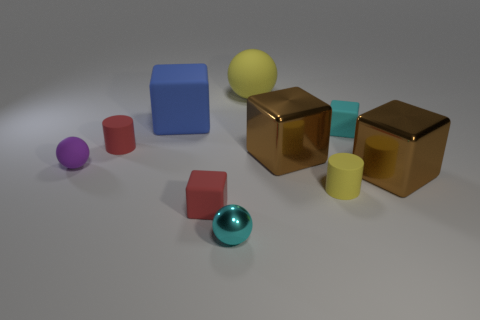Subtract all small red rubber blocks. How many blocks are left? 4 Subtract all cyan blocks. How many blocks are left? 4 Subtract 1 blocks. How many blocks are left? 4 Subtract all yellow cubes. Subtract all gray cylinders. How many cubes are left? 5 Subtract all spheres. How many objects are left? 7 Add 6 tiny purple objects. How many tiny purple objects are left? 7 Add 5 yellow spheres. How many yellow spheres exist? 6 Subtract 0 brown spheres. How many objects are left? 10 Subtract all large purple metal cylinders. Subtract all small red cubes. How many objects are left? 9 